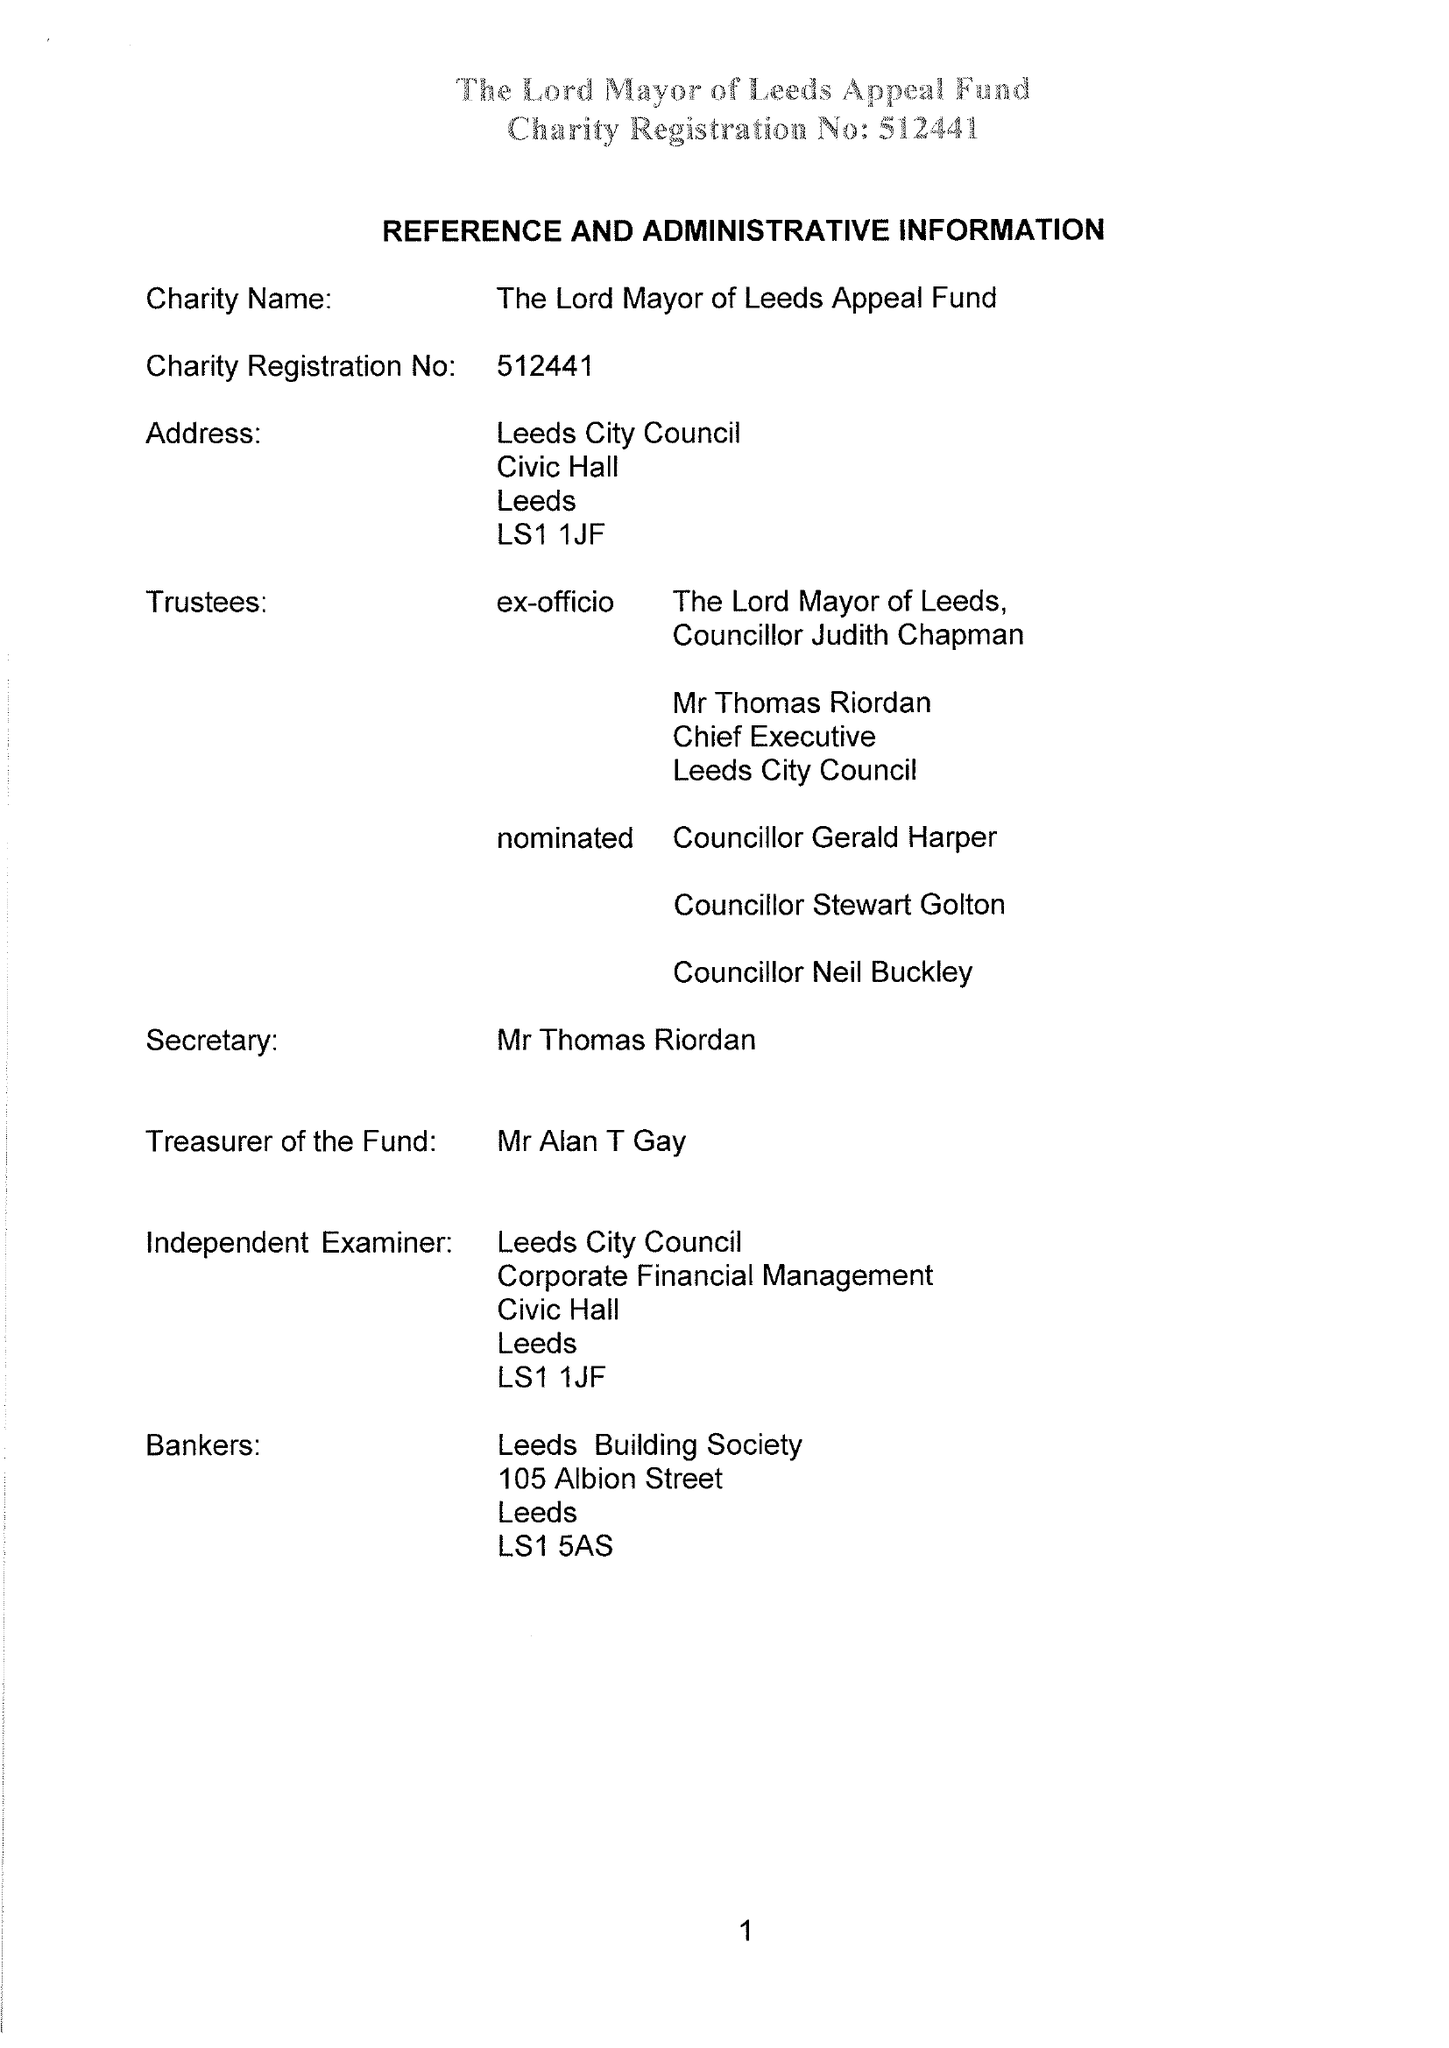What is the value for the charity_number?
Answer the question using a single word or phrase. 512441 